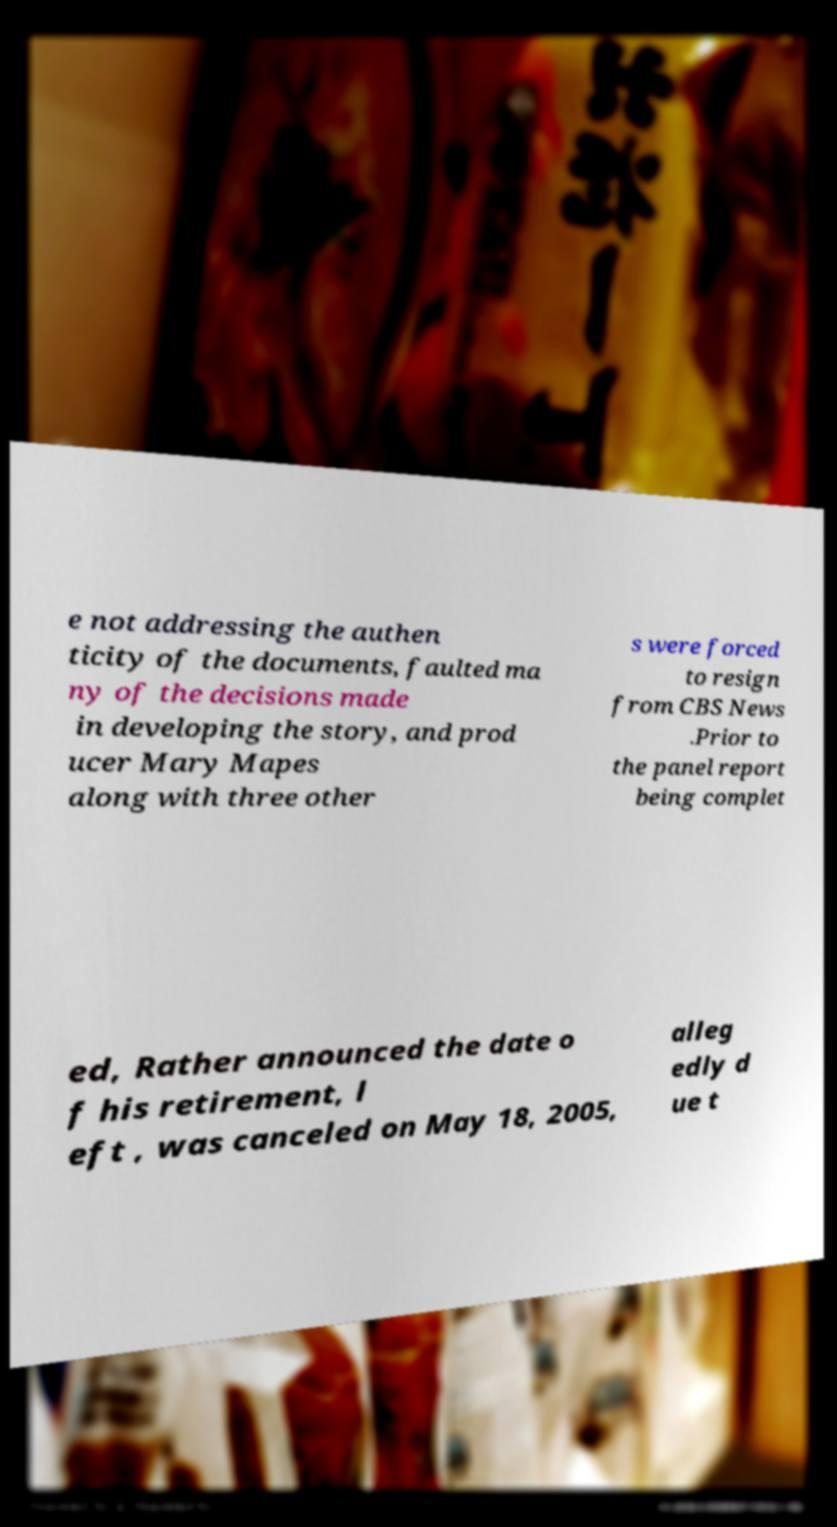For documentation purposes, I need the text within this image transcribed. Could you provide that? e not addressing the authen ticity of the documents, faulted ma ny of the decisions made in developing the story, and prod ucer Mary Mapes along with three other s were forced to resign from CBS News .Prior to the panel report being complet ed, Rather announced the date o f his retirement, l eft , was canceled on May 18, 2005, alleg edly d ue t 